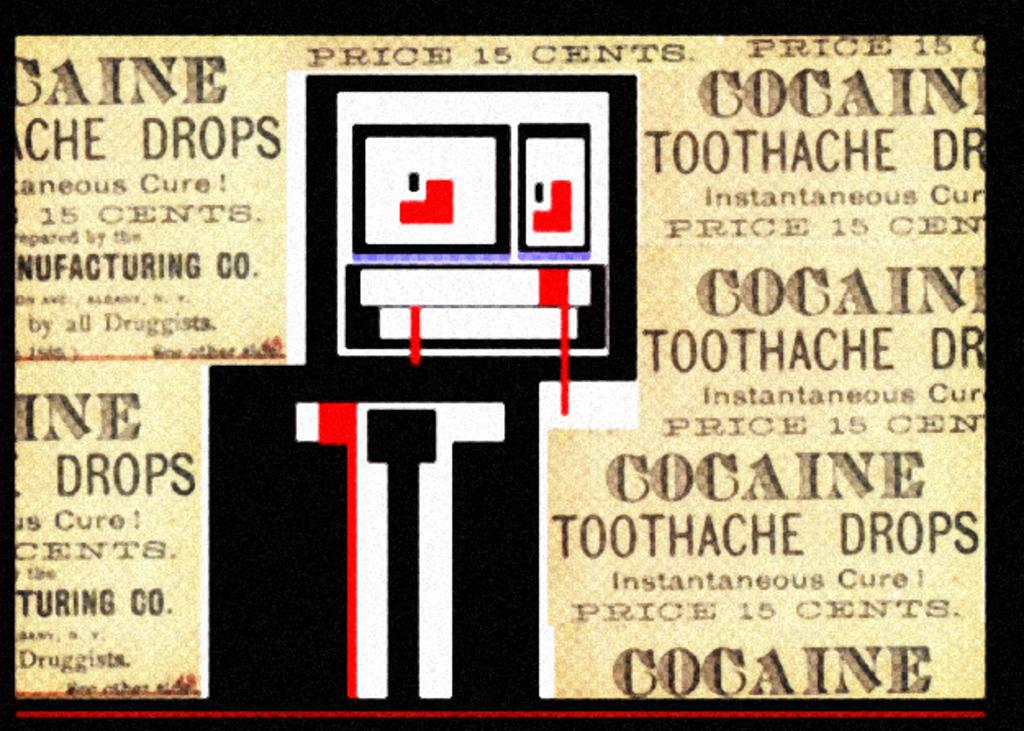<image>
Provide a brief description of the given image. A poster has multiple adds for Cocaine Toothache Drops with price 15 cents. 